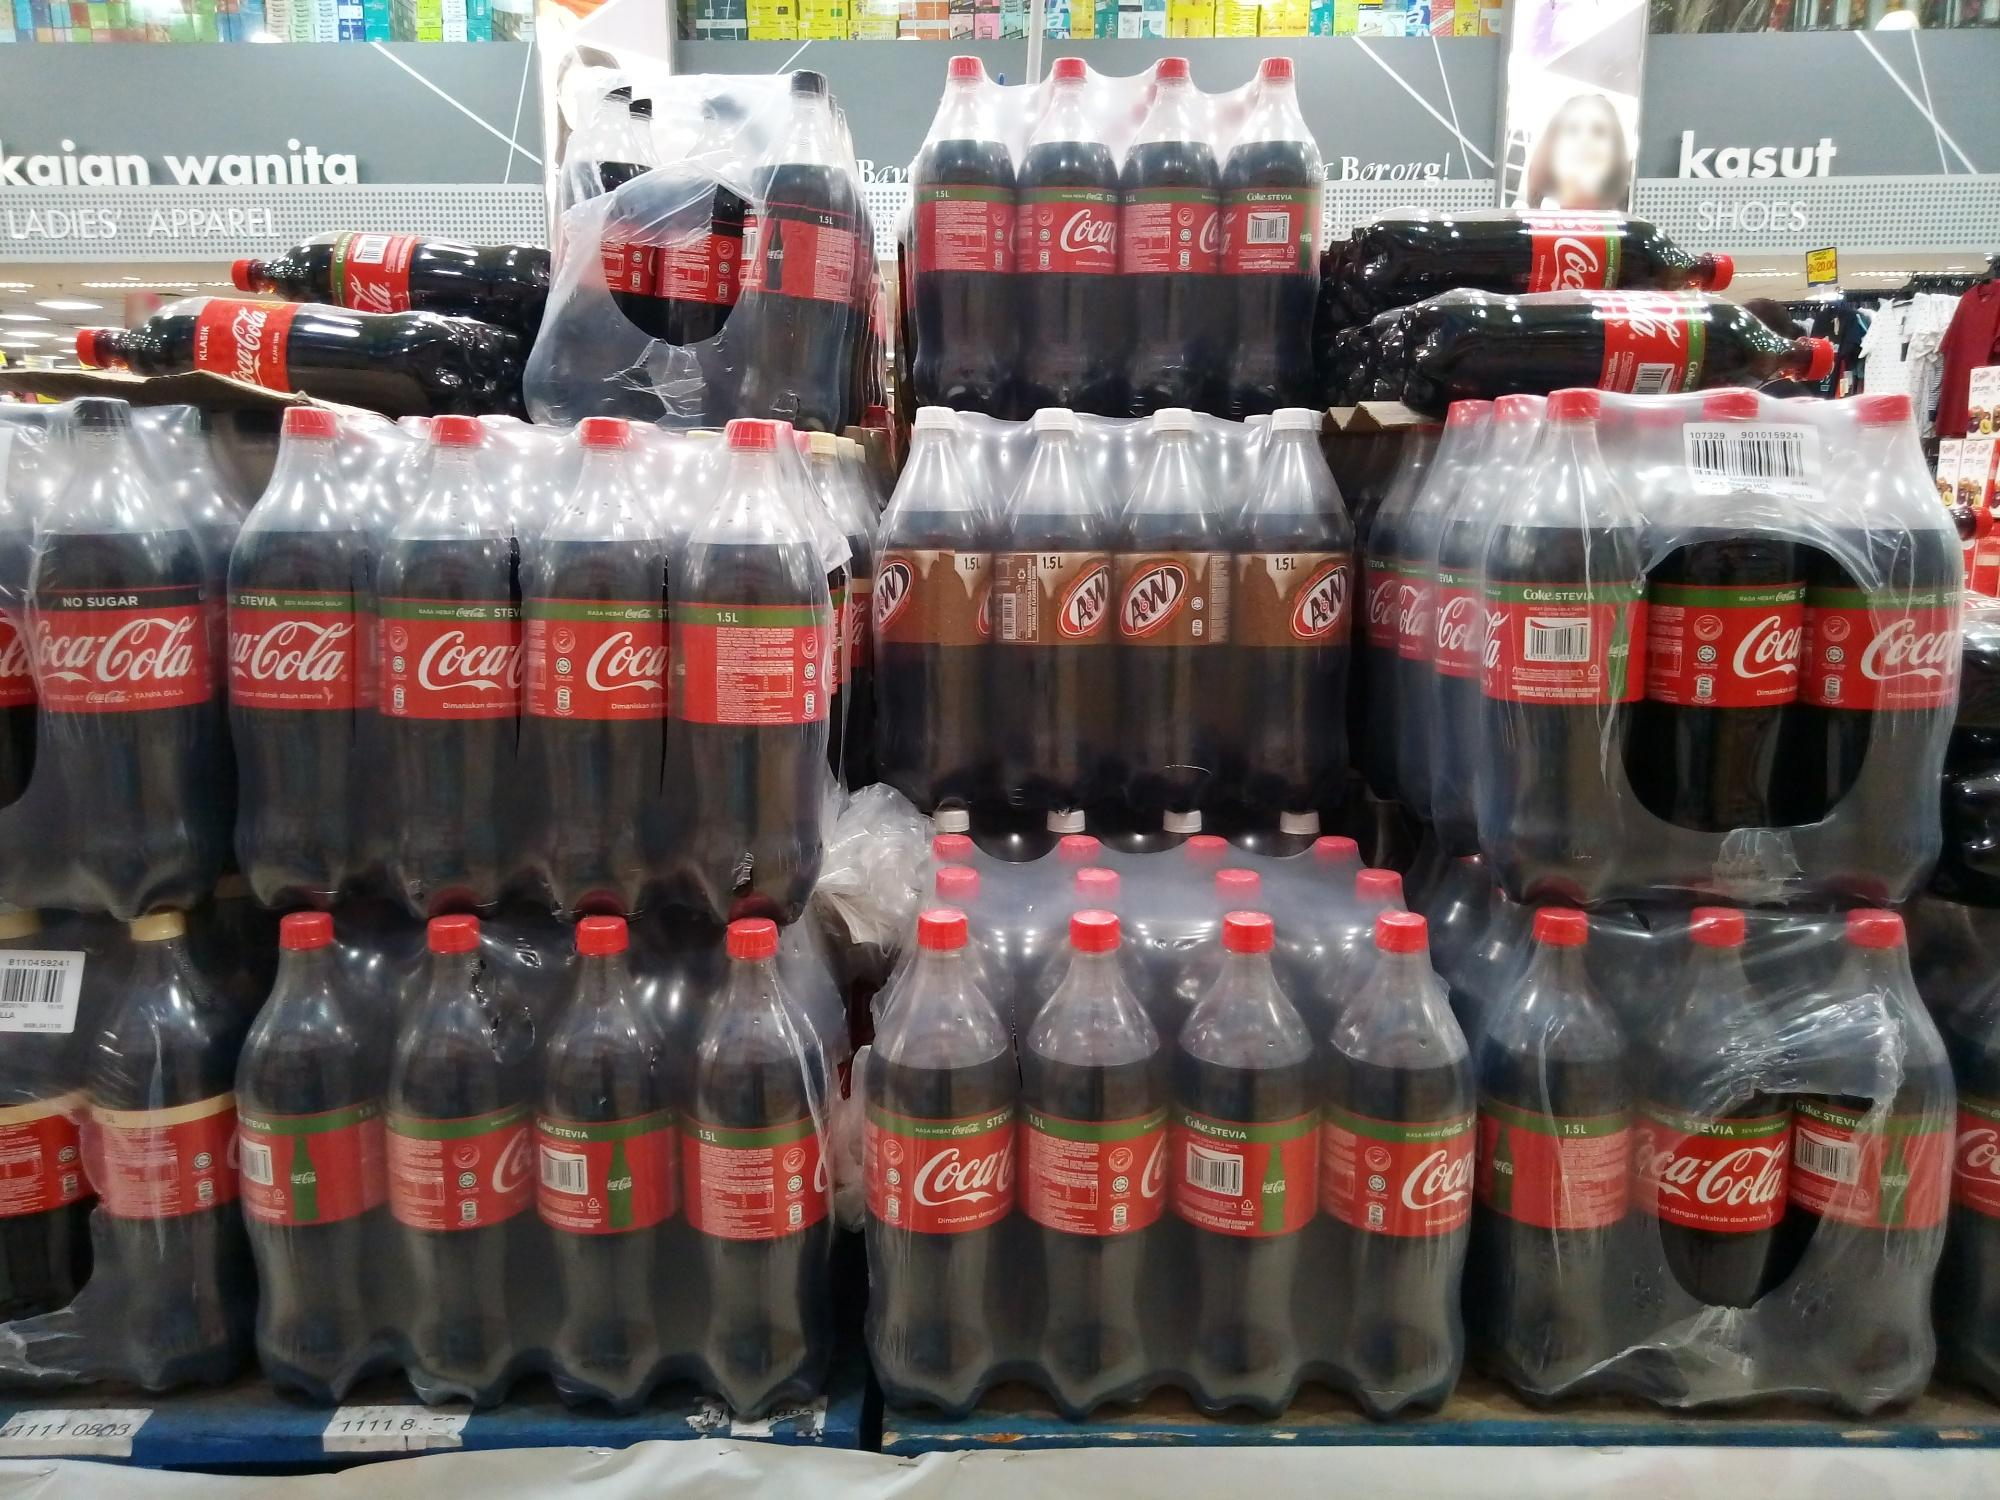Realistic scenario: A customer quickly grabbing a bottle. A customer, in a rush to complete their last-minute shopping, spots the neatly arranged pyramid of Coca-Cola bottles from across the aisle. With a purposeful stride, they navigate through the bustling store, heading straight for the vibrant display. In a swift motion, they pick a bottle from the center, its cool surface a sharp contrast to the warm, bustling environment of the store. Without a moment to lose, they head towards the checkout, the familiar red label promising a refreshing pause amidst their busy day. 